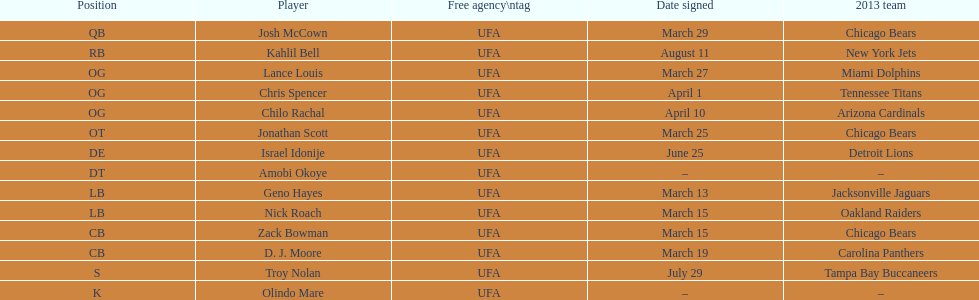Parse the full table. {'header': ['Position', 'Player', 'Free agency\\ntag', 'Date signed', '2013 team'], 'rows': [['QB', 'Josh McCown', 'UFA', 'March 29', 'Chicago Bears'], ['RB', 'Kahlil Bell', 'UFA', 'August 11', 'New York Jets'], ['OG', 'Lance Louis', 'UFA', 'March 27', 'Miami Dolphins'], ['OG', 'Chris Spencer', 'UFA', 'April 1', 'Tennessee Titans'], ['OG', 'Chilo Rachal', 'UFA', 'April 10', 'Arizona Cardinals'], ['OT', 'Jonathan Scott', 'UFA', 'March 25', 'Chicago Bears'], ['DE', 'Israel Idonije', 'UFA', 'June 25', 'Detroit Lions'], ['DT', 'Amobi Okoye', 'UFA', '–', '–'], ['LB', 'Geno Hayes', 'UFA', 'March 13', 'Jacksonville Jaguars'], ['LB', 'Nick Roach', 'UFA', 'March 15', 'Oakland Raiders'], ['CB', 'Zack Bowman', 'UFA', 'March 15', 'Chicago Bears'], ['CB', 'D. J. Moore', 'UFA', 'March 19', 'Carolina Panthers'], ['S', 'Troy Nolan', 'UFA', 'July 29', 'Tampa Bay Buccaneers'], ['K', 'Olindo Mare', 'UFA', '–', '–']]} How many players were acquired in march? 7. 